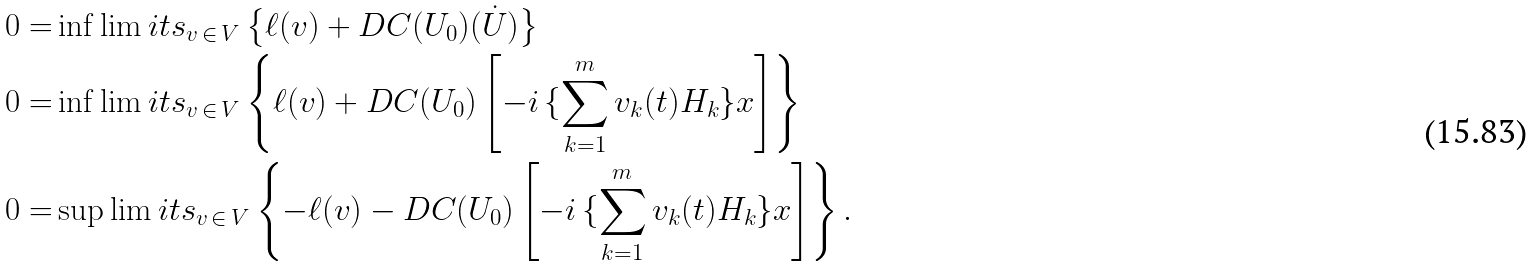Convert formula to latex. <formula><loc_0><loc_0><loc_500><loc_500>0 = & \inf \lim i t s _ { v \, \in \, V } \left \{ \ell ( v ) + D C ( U _ { 0 } ) ( \dot { U } ) \right \} \\ 0 = & \inf \lim i t s _ { v \, \in \, V } \left \{ \ell ( v ) + D C ( U _ { 0 } ) \left [ - i \, \{ \sum _ { k = 1 } ^ { m } v _ { k } ( t ) H _ { k } \} x \right ] \right \} \\ 0 = & \sup \lim i t s _ { v \, \in \, V } \left \{ - \ell ( v ) - D C ( U _ { 0 } ) \left [ - i \, \{ \sum _ { k = 1 } ^ { m } v _ { k } ( t ) H _ { k } \} x \right ] \right \} .</formula> 